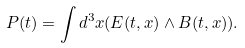Convert formula to latex. <formula><loc_0><loc_0><loc_500><loc_500>P ( t ) = \int d ^ { 3 } x ( E ( t , x ) \wedge B ( t , x ) ) .</formula> 